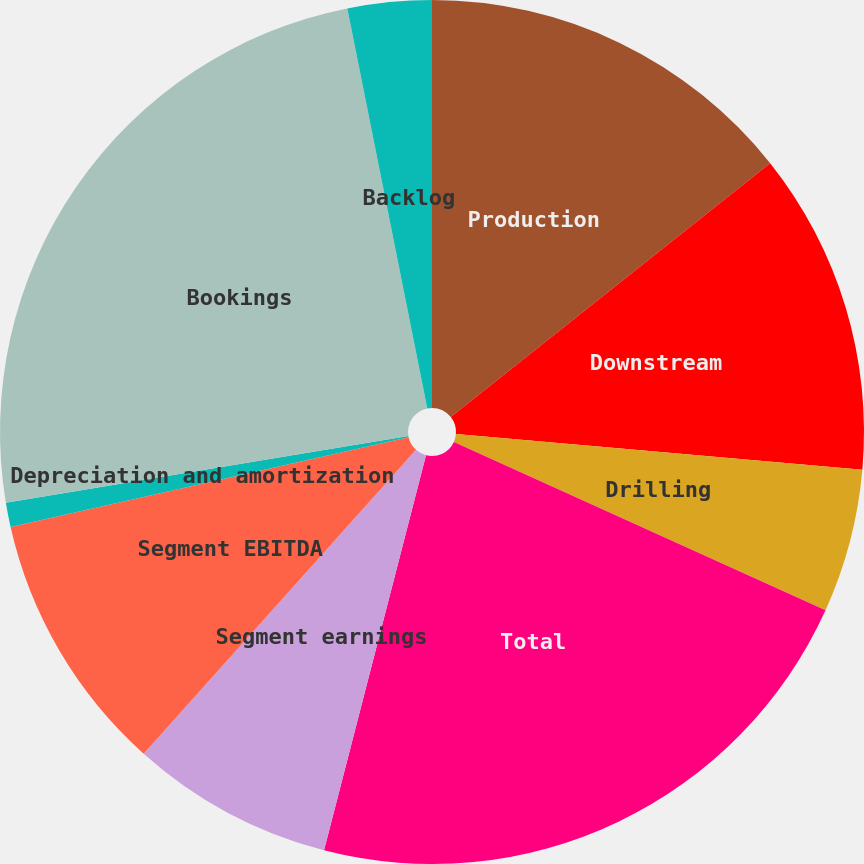Convert chart to OTSL. <chart><loc_0><loc_0><loc_500><loc_500><pie_chart><fcel>Production<fcel>Downstream<fcel>Drilling<fcel>Total<fcel>Segment earnings<fcel>Segment EBITDA<fcel>Depreciation and amortization<fcel>Bookings<fcel>Backlog<nl><fcel>14.31%<fcel>12.08%<fcel>5.38%<fcel>22.25%<fcel>7.61%<fcel>9.84%<fcel>0.91%<fcel>24.48%<fcel>3.14%<nl></chart> 